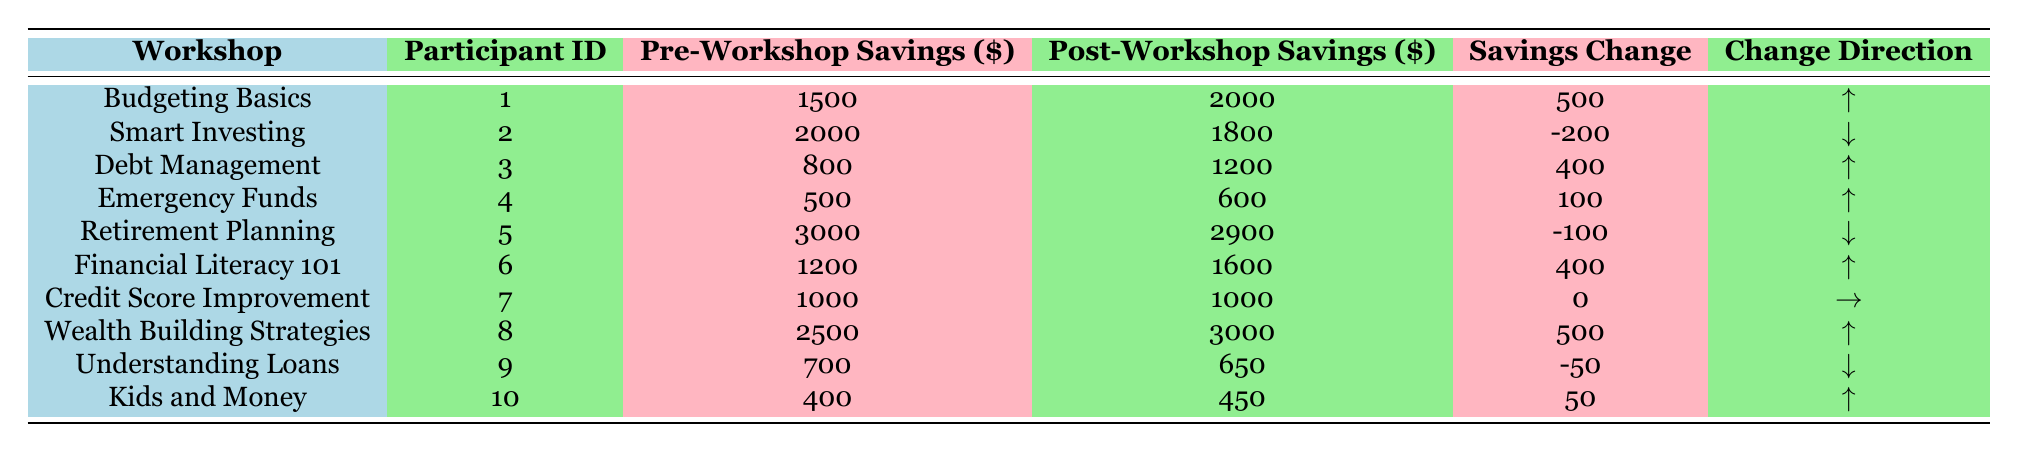What is the total pre-workshop savings for all participants? To find the total pre-workshop savings, add the values from the "Pre-Workshop Savings" column: 1500 + 2000 + 800 + 500 + 3000 + 1200 + 1000 + 2500 + 700 + 400 = 12000.
Answer: 12000 Which workshop had the highest post-workshop savings? The highest post-workshop savings is found by comparing the "Post-Workshop Savings" column: the values are 2000, 1800, 1200, 600, 2900, 1600, 1000, 3000, 650, and 450. The highest value is 3000 from "Wealth Building Strategies."
Answer: Wealth Building Strategies How many workshops resulted in an increase in savings? To determine the number of workshops with increased savings, look for rows where "Savings Change" is "Increase": these are Budgeting Basics, Debt Management, Emergency Funds, Financial Literacy 101, Wealth Building Strategies, and Kids and Money. This totals to 6 workshops.
Answer: 6 What is the median change in savings after attending the workshops? First, the savings changes must be converted to numerical values: 500, -200, 400, 100, -100, 400, 0, 500, -50, 50. Arranging these numbers in order: -200, -100, -50, 0, 50, 100, 400, 400, 500, 500. The median is the average of the 5th and 6th numbers (50 and 100): (50 + 100)/2 = 75.
Answer: 75 Did more participants experience a decrease or an increase in savings post-workshop? Count how many participants had "Decrease" or "Increase" in the "Savings Change" column. There are 3 who decreased (Smart Investing, Retirement Planning, Understanding Loans) and 6 who increased. Thus, more participants increased their savings than decreased.
Answer: More participants increased savings 